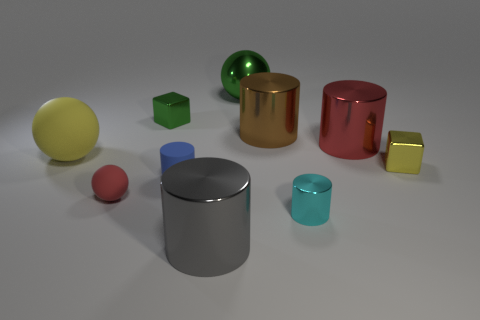What number of other things are there of the same color as the big matte thing?
Your response must be concise. 1. Does the tiny matte sphere have the same color as the big cylinder to the right of the big brown shiny cylinder?
Your answer should be compact. Yes. The thing that is behind the large matte object and left of the large gray thing is what color?
Your response must be concise. Green. Are there any other tiny shiny things of the same shape as the yellow shiny object?
Keep it short and to the point. Yes. There is a block on the left side of the large red metallic object; are there any large green shiny objects that are to the left of it?
Your response must be concise. No. How many things are either big metallic cylinders on the left side of the big red shiny cylinder or tiny blue matte cylinders that are on the left side of the big green shiny ball?
Offer a very short reply. 3. What number of objects are either spheres or large red cylinders that are behind the large yellow matte ball?
Give a very brief answer. 4. There is a red object behind the big object to the left of the tiny block that is on the left side of the big gray cylinder; what is its size?
Provide a short and direct response. Large. What material is the ball that is the same size as the blue rubber cylinder?
Provide a succinct answer. Rubber. Is there a green ball of the same size as the red metal object?
Provide a succinct answer. Yes. 